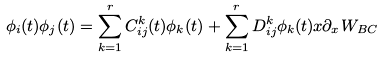<formula> <loc_0><loc_0><loc_500><loc_500>\phi _ { i } ( t ) \phi _ { j } ( t ) = \sum _ { k = 1 } ^ { r } C _ { i j } ^ { k } ( t ) \phi _ { k } ( t ) + \sum _ { k = 1 } ^ { r } D _ { i j } ^ { k } \phi _ { k } ( t ) x \partial _ { x } W _ { B C }</formula> 